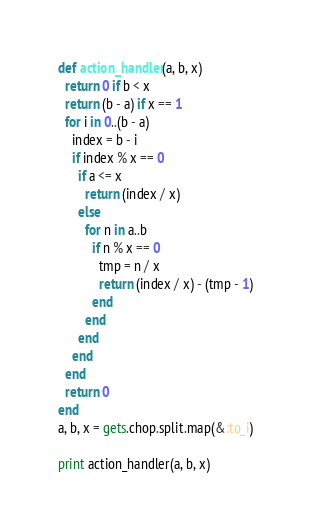Convert code to text. <code><loc_0><loc_0><loc_500><loc_500><_Ruby_>def action_handler(a, b, x)
  return 0 if b < x
  return (b - a) if x == 1
  for i in 0..(b - a)
    index = b - i
    if index % x == 0
      if a <= x
        return (index / x)
      else
        for n in a..b
          if n % x == 0
            tmp = n / x
            return (index / x) - (tmp - 1)
          end
        end
      end
    end
  end
  return 0
end
a, b, x = gets.chop.split.map(&:to_i)

print action_handler(a, b, x)
</code> 